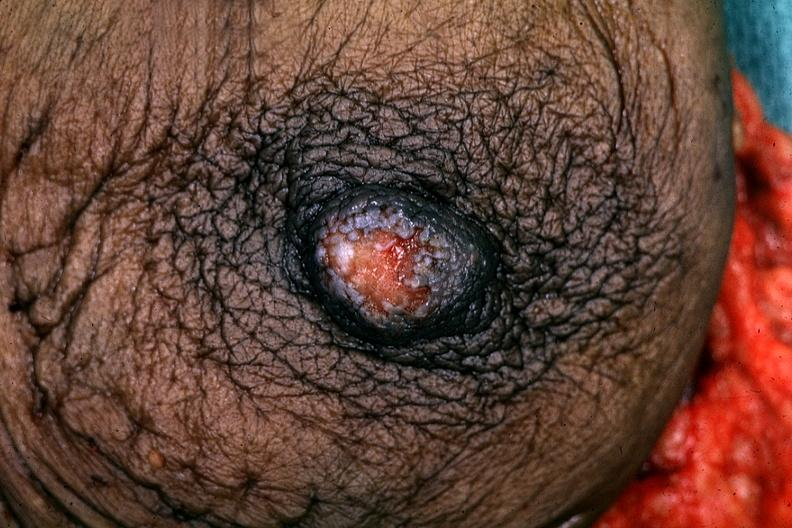does macerated stillborn show excised breast good example?
Answer the question using a single word or phrase. No 